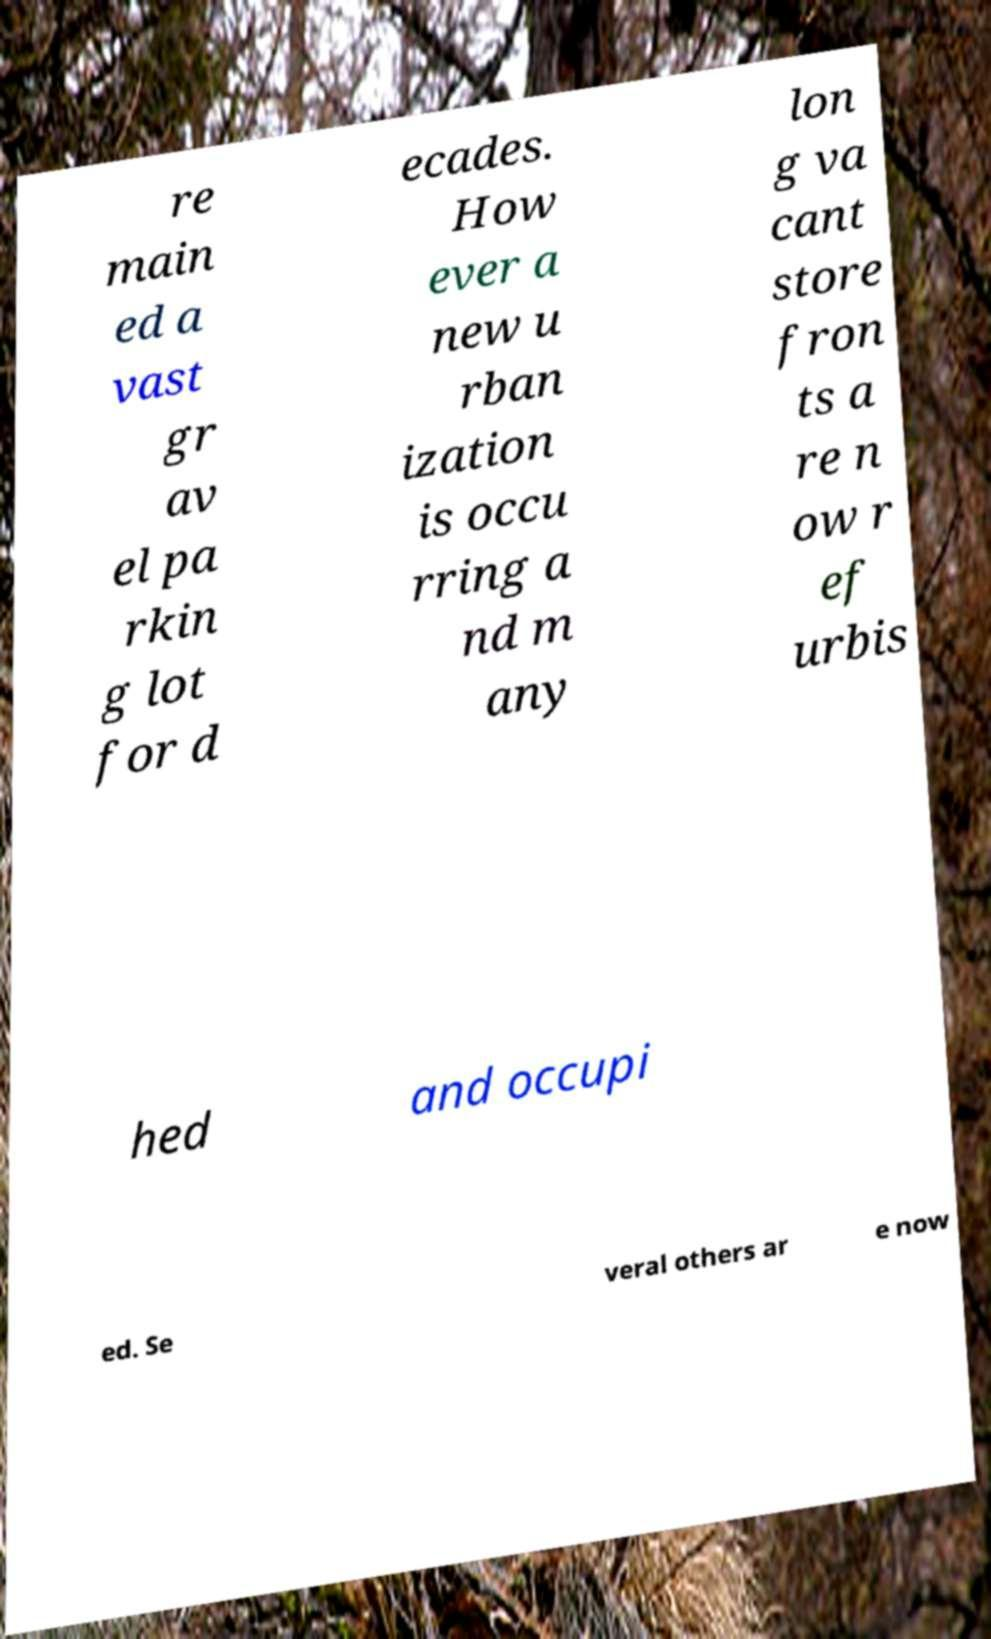Can you accurately transcribe the text from the provided image for me? re main ed a vast gr av el pa rkin g lot for d ecades. How ever a new u rban ization is occu rring a nd m any lon g va cant store fron ts a re n ow r ef urbis hed and occupi ed. Se veral others ar e now 